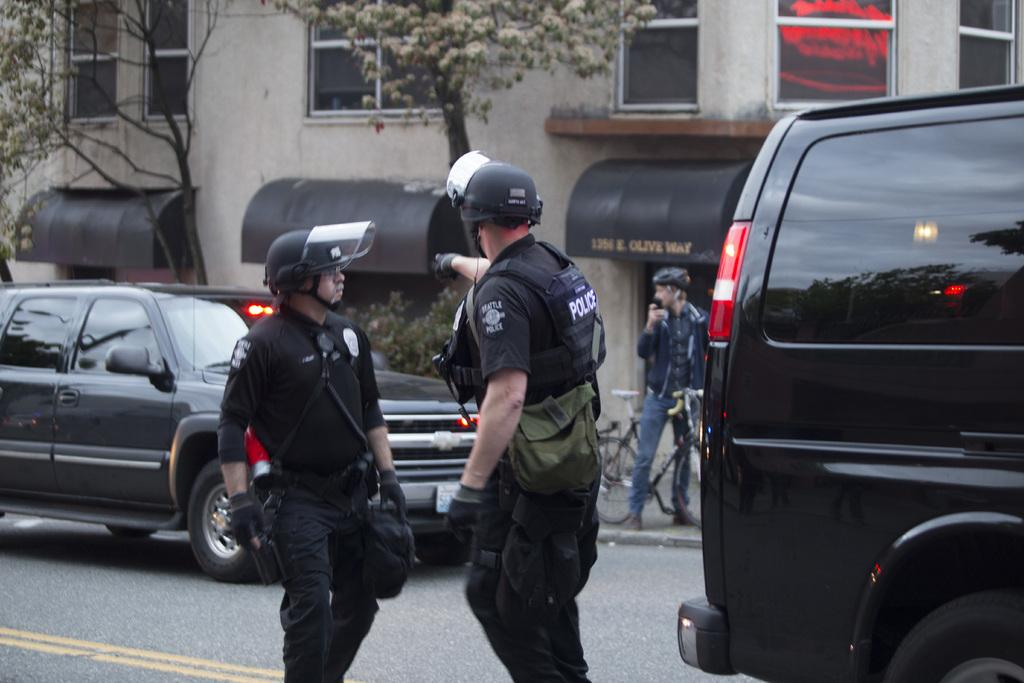How many people are in the image? There are three people standing in the image. What is the person near doing? The person is standing near a bicycle. What else can be seen on the road in the image? Vehicles are present on the road in the image. What type of structure is visible in the image? There is at least one building in the image. What natural elements can be seen in the image? Trees are visible in the image. What type of glue is being used to stick the bag to the sugar in the image? There is no bag, glue, or sugar present in the image. 